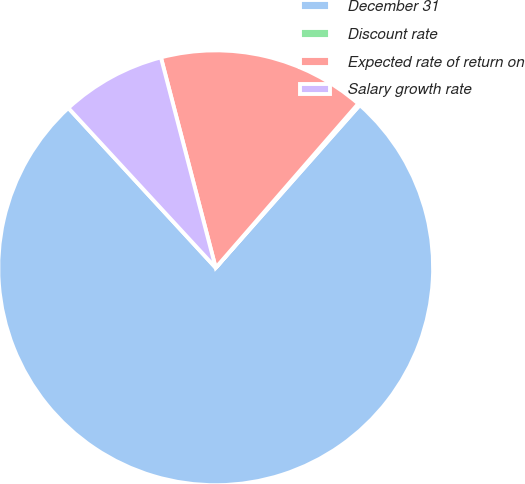Convert chart to OTSL. <chart><loc_0><loc_0><loc_500><loc_500><pie_chart><fcel>December 31<fcel>Discount rate<fcel>Expected rate of return on<fcel>Salary growth rate<nl><fcel>76.61%<fcel>0.15%<fcel>15.44%<fcel>7.8%<nl></chart> 